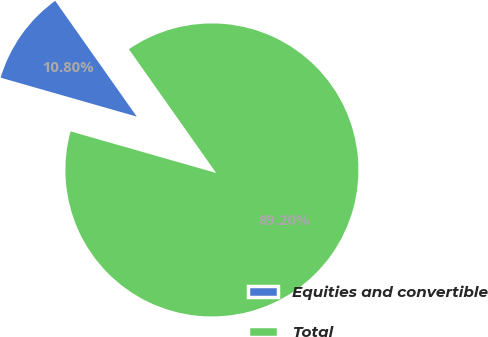<chart> <loc_0><loc_0><loc_500><loc_500><pie_chart><fcel>Equities and convertible<fcel>Total<nl><fcel>10.8%<fcel>89.2%<nl></chart> 